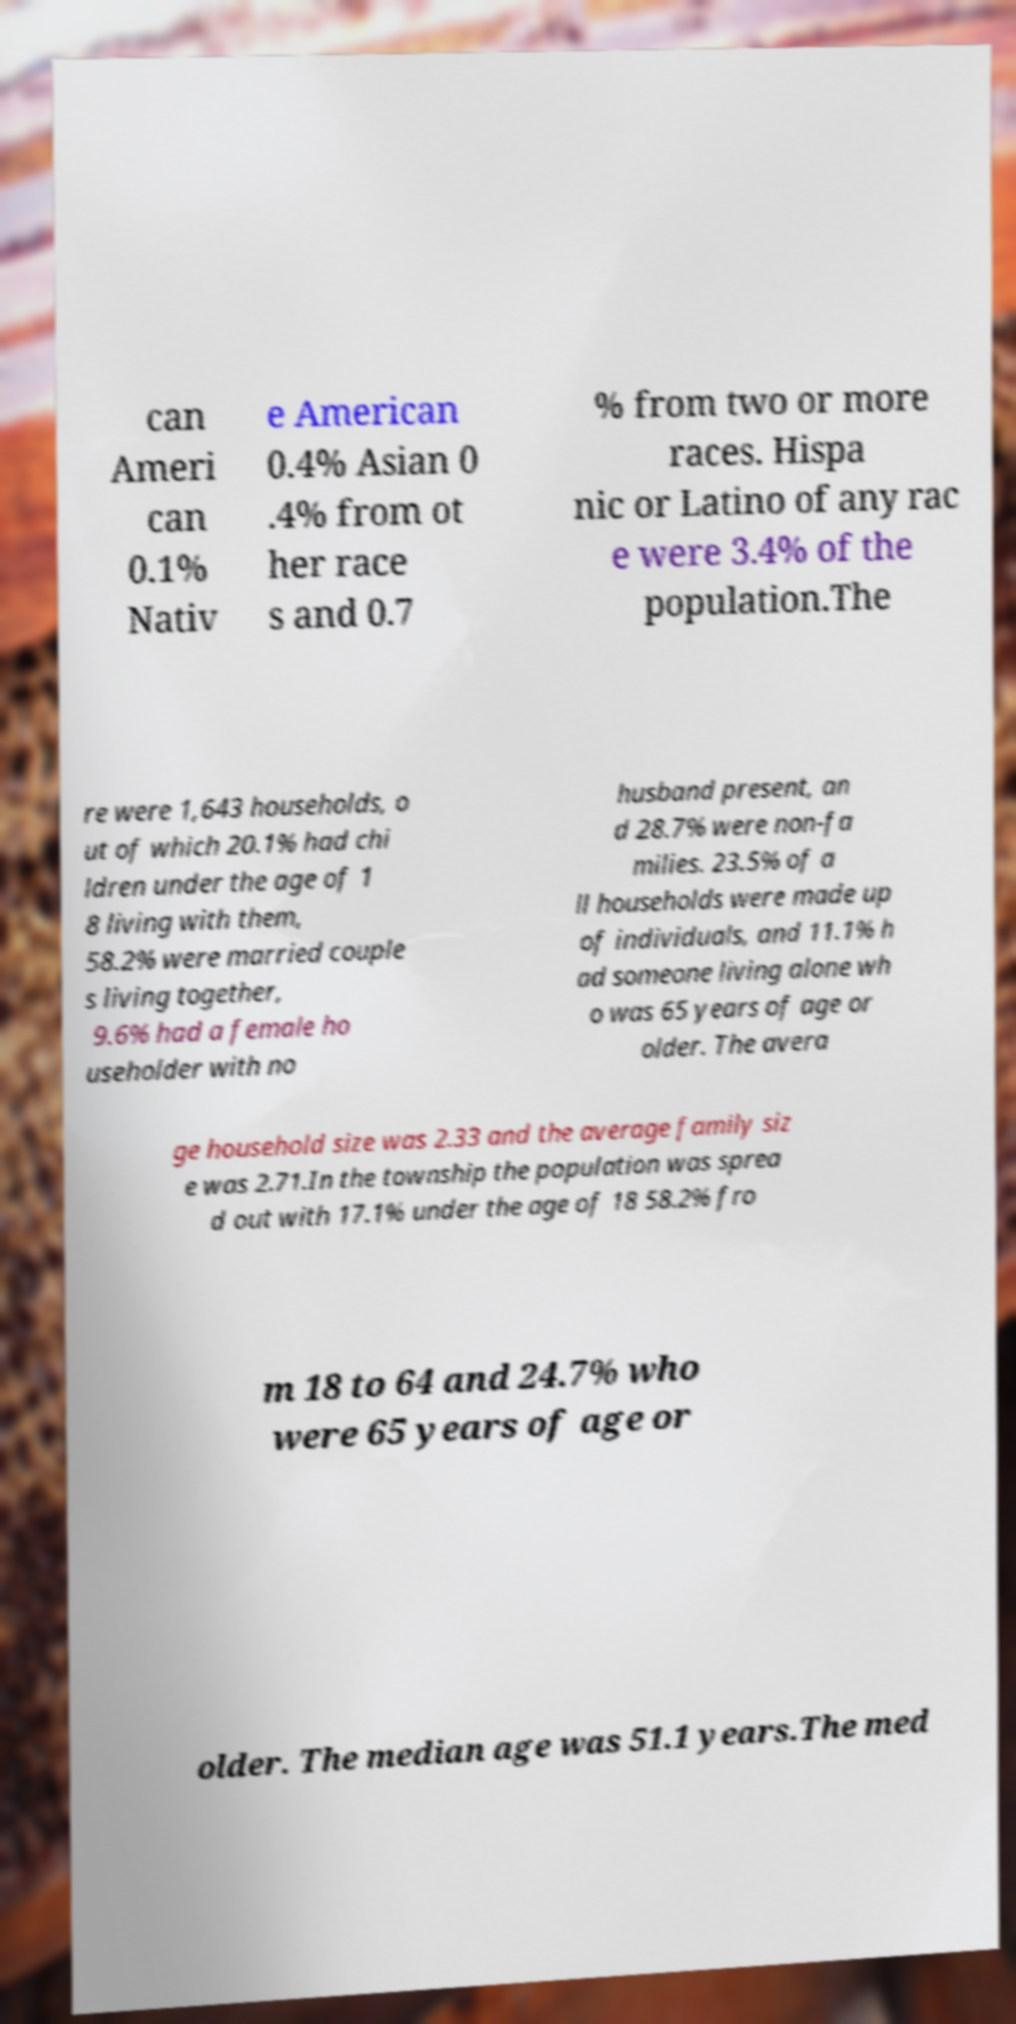Please identify and transcribe the text found in this image. can Ameri can 0.1% Nativ e American 0.4% Asian 0 .4% from ot her race s and 0.7 % from two or more races. Hispa nic or Latino of any rac e were 3.4% of the population.The re were 1,643 households, o ut of which 20.1% had chi ldren under the age of 1 8 living with them, 58.2% were married couple s living together, 9.6% had a female ho useholder with no husband present, an d 28.7% were non-fa milies. 23.5% of a ll households were made up of individuals, and 11.1% h ad someone living alone wh o was 65 years of age or older. The avera ge household size was 2.33 and the average family siz e was 2.71.In the township the population was sprea d out with 17.1% under the age of 18 58.2% fro m 18 to 64 and 24.7% who were 65 years of age or older. The median age was 51.1 years.The med 